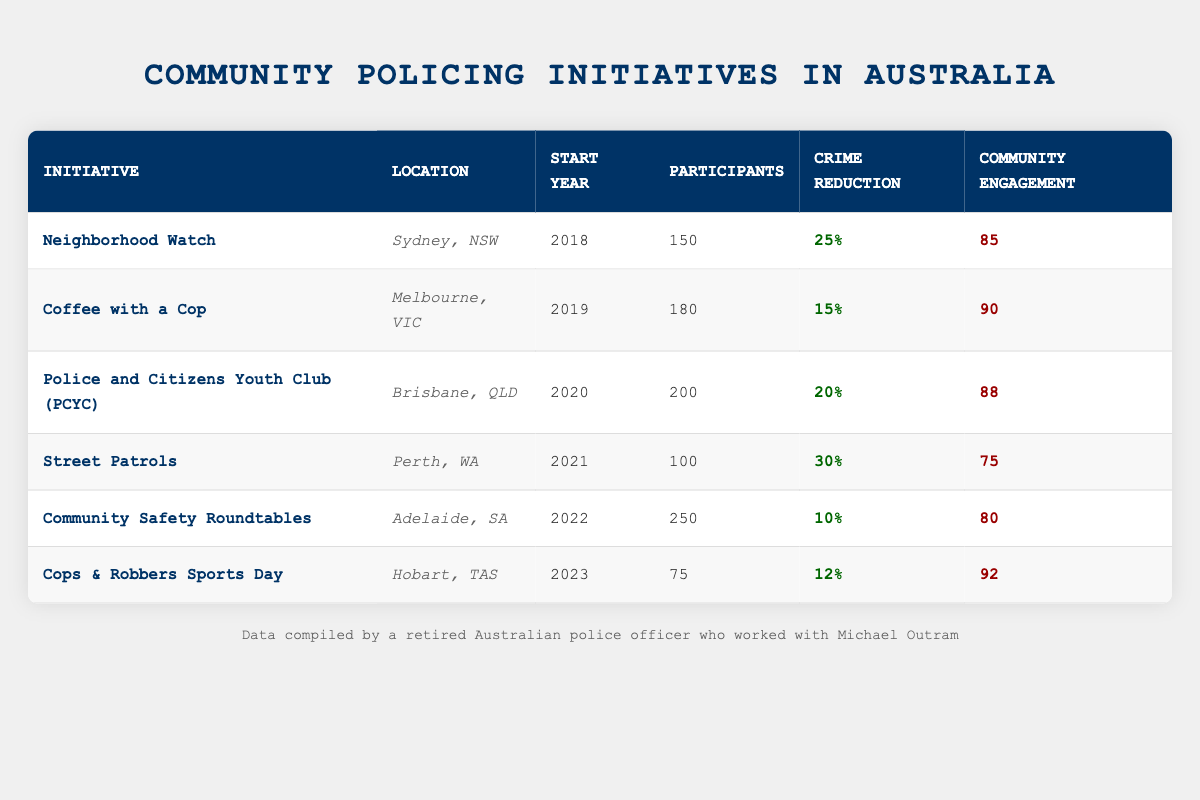What is the crime reduction percentage for the Street Patrols initiative? The table shows that the crime reduction percentage for the Street Patrols initiative is listed under the corresponding row. Looking at the "crime reduction percentage" column for Street Patrols, it states 30%.
Answer: 30% Which initiative had the highest community engagement score? To find the highest community engagement score, we compare the scores in the "Community Engagement" column for all initiatives. The highest score is 92, which corresponds to the Cops & Robbers Sports Day initiative.
Answer: Cops & Robbers Sports Day How many participants were involved in the Neighborhood Watch initiative? The table directly lists the number of participants for each initiative. For Neighborhood Watch, the participants listed in the respective row is 150.
Answer: 150 What is the average crime reduction percentage across all initiatives? To calculate the average, we first sum the crime reduction percentages (25 + 15 + 20 + 30 + 10 + 12 = 112) and then divide by the number of initiatives (6). Thus, the average crime reduction percentage is 112 / 6 = 18.67%.
Answer: 18.67% Was the Police and Citizens Youth Club (PCYC) started before 2020? Checking the "Start Year" column, we see that PCYC started in 2020. To determine if it started before 2020, we check for any earlier year. Since 2020 is not before itself, the statement is false.
Answer: No Which initiative had more participants: Community Safety Roundtables or Coffee with a Cop? We compare the participant numbers in the "Participants" column for both initiatives. Community Safety Roundtables has 250 participants, while Coffee with a Cop has 180 participants. Since 250 is greater than 180, Community Safety Roundtables had more participants.
Answer: Community Safety Roundtables Is the crime reduction percentage for Cops & Robbers Sports Day greater than that for Neighborhood Watch? According to the table, Cops & Robbers Sports Day has a crime reduction of 12%, while Neighborhood Watch has a reduction of 25%. Since 12% is less than 25%, the statement is false.
Answer: No What is the total number of participants across all community policing initiatives? To calculate the total number of participants, we sum all the participant numbers from the "Participants" column (150 + 180 + 200 + 100 + 250 + 75 = 955). Therefore, the total number of participants is 955.
Answer: 955 